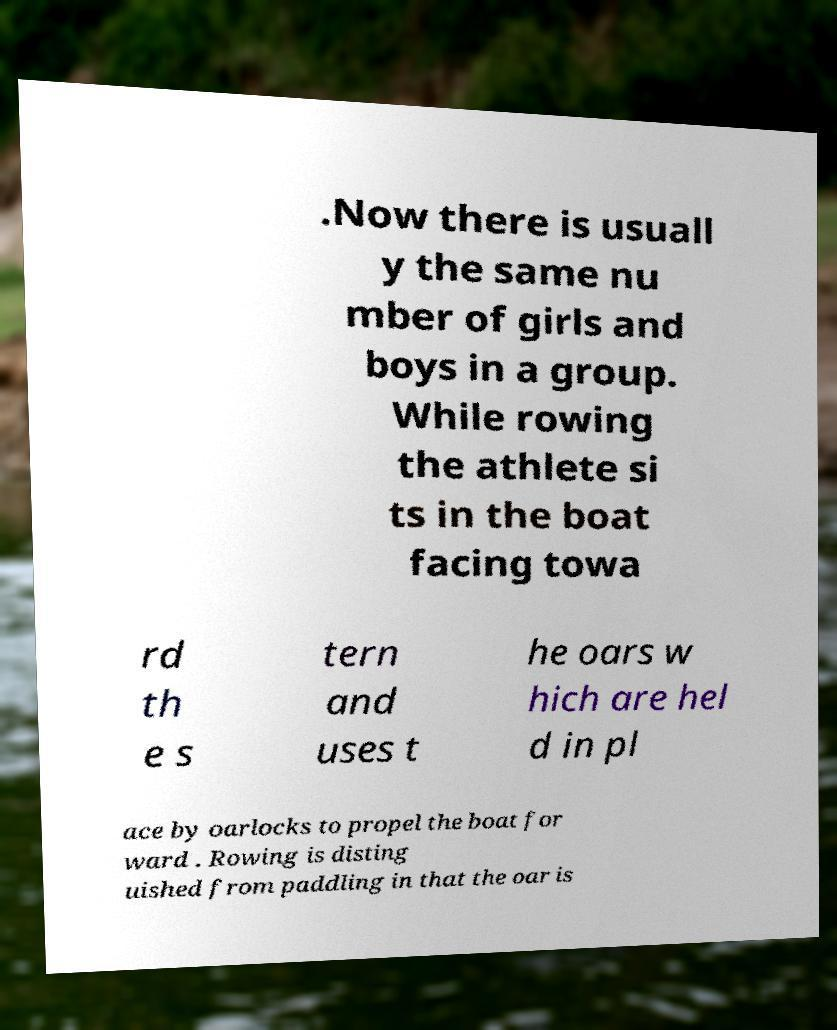Please identify and transcribe the text found in this image. .Now there is usuall y the same nu mber of girls and boys in a group. While rowing the athlete si ts in the boat facing towa rd th e s tern and uses t he oars w hich are hel d in pl ace by oarlocks to propel the boat for ward . Rowing is disting uished from paddling in that the oar is 